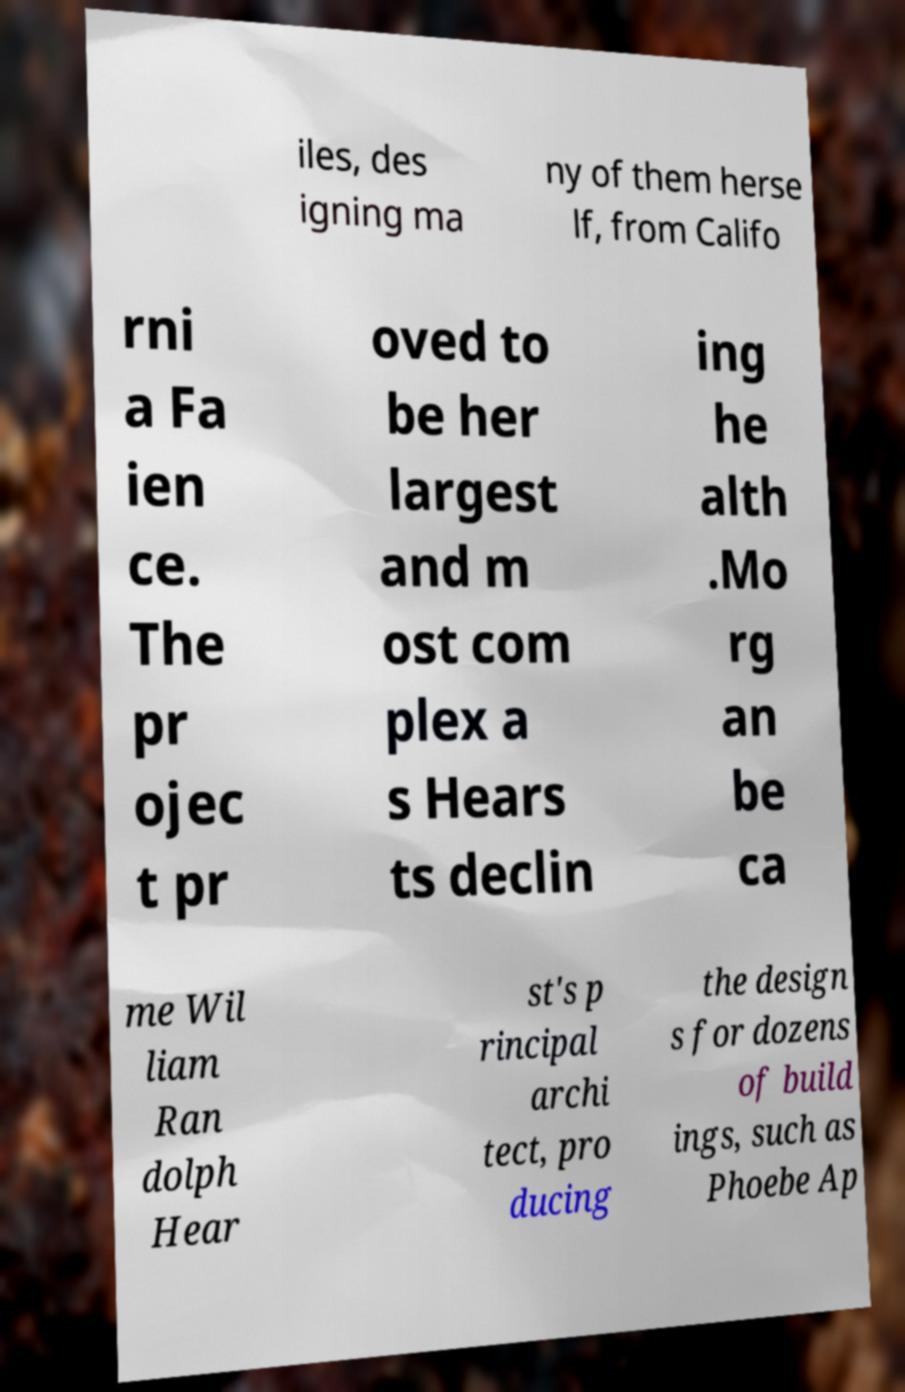Can you read and provide the text displayed in the image?This photo seems to have some interesting text. Can you extract and type it out for me? iles, des igning ma ny of them herse lf, from Califo rni a Fa ien ce. The pr ojec t pr oved to be her largest and m ost com plex a s Hears ts declin ing he alth .Mo rg an be ca me Wil liam Ran dolph Hear st's p rincipal archi tect, pro ducing the design s for dozens of build ings, such as Phoebe Ap 